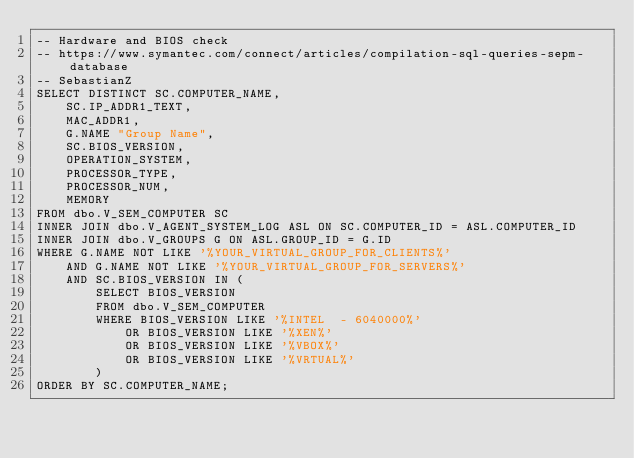<code> <loc_0><loc_0><loc_500><loc_500><_SQL_>-- Hardware and BIOS check
-- https://www.symantec.com/connect/articles/compilation-sql-queries-sepm-database
-- SebastianZ
SELECT DISTINCT SC.COMPUTER_NAME,
	SC.IP_ADDR1_TEXT,
	MAC_ADDR1,
	G.NAME "Group Name",
	SC.BIOS_VERSION,
	OPERATION_SYSTEM,
	PROCESSOR_TYPE,
	PROCESSOR_NUM,
	MEMORY
FROM dbo.V_SEM_COMPUTER SC
INNER JOIN dbo.V_AGENT_SYSTEM_LOG ASL ON SC.COMPUTER_ID = ASL.COMPUTER_ID
INNER JOIN dbo.V_GROUPS G ON ASL.GROUP_ID = G.ID
WHERE G.NAME NOT LIKE '%YOUR_VIRTUAL_GROUP_FOR_CLIENTS%'
	AND G.NAME NOT LIKE '%YOUR_VIRTUAL_GROUP_FOR_SERVERS%'
	AND SC.BIOS_VERSION IN (
		SELECT BIOS_VERSION
		FROM dbo.V_SEM_COMPUTER
		WHERE BIOS_VERSION LIKE '%INTEL  - 6040000%'
			OR BIOS_VERSION LIKE '%XEN%'
			OR BIOS_VERSION LIKE '%VBOX%'
			OR BIOS_VERSION LIKE '%VRTUAL%'
		)
ORDER BY SC.COMPUTER_NAME;</code> 